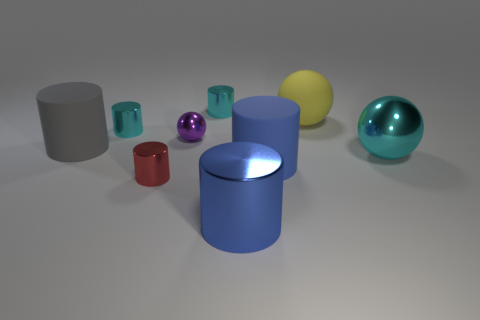Subtract 3 cylinders. How many cylinders are left? 3 Subtract all blue cylinders. How many cylinders are left? 4 Subtract all tiny red cylinders. How many cylinders are left? 5 Subtract all red cylinders. Subtract all red spheres. How many cylinders are left? 5 Subtract all cylinders. How many objects are left? 3 Subtract 1 cyan balls. How many objects are left? 8 Subtract all red matte cubes. Subtract all big balls. How many objects are left? 7 Add 1 rubber cylinders. How many rubber cylinders are left? 3 Add 2 large objects. How many large objects exist? 7 